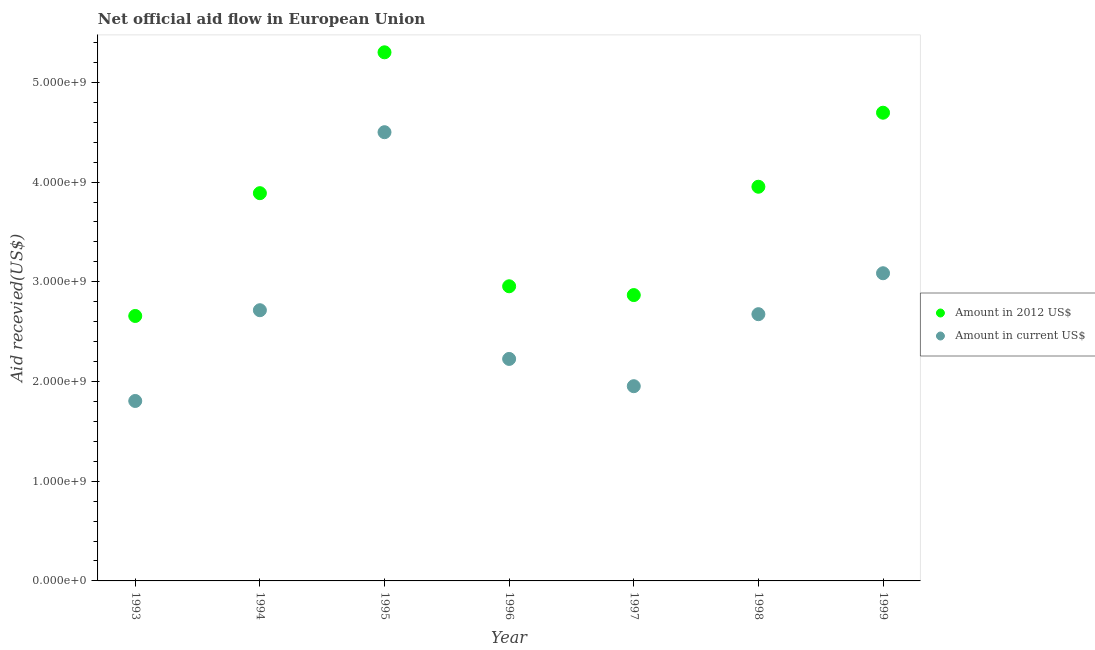How many different coloured dotlines are there?
Make the answer very short. 2. Is the number of dotlines equal to the number of legend labels?
Make the answer very short. Yes. What is the amount of aid received(expressed in 2012 us$) in 1995?
Ensure brevity in your answer.  5.30e+09. Across all years, what is the maximum amount of aid received(expressed in 2012 us$)?
Provide a succinct answer. 5.30e+09. Across all years, what is the minimum amount of aid received(expressed in us$)?
Your answer should be compact. 1.80e+09. In which year was the amount of aid received(expressed in us$) maximum?
Give a very brief answer. 1995. In which year was the amount of aid received(expressed in us$) minimum?
Provide a succinct answer. 1993. What is the total amount of aid received(expressed in 2012 us$) in the graph?
Your answer should be compact. 2.63e+1. What is the difference between the amount of aid received(expressed in 2012 us$) in 1998 and that in 1999?
Provide a succinct answer. -7.42e+08. What is the difference between the amount of aid received(expressed in 2012 us$) in 1997 and the amount of aid received(expressed in us$) in 1996?
Ensure brevity in your answer.  6.40e+08. What is the average amount of aid received(expressed in us$) per year?
Your response must be concise. 2.71e+09. In the year 1997, what is the difference between the amount of aid received(expressed in us$) and amount of aid received(expressed in 2012 us$)?
Provide a succinct answer. -9.14e+08. In how many years, is the amount of aid received(expressed in us$) greater than 4000000000 US$?
Offer a very short reply. 1. What is the ratio of the amount of aid received(expressed in 2012 us$) in 1993 to that in 1999?
Give a very brief answer. 0.57. Is the difference between the amount of aid received(expressed in us$) in 1993 and 1996 greater than the difference between the amount of aid received(expressed in 2012 us$) in 1993 and 1996?
Your answer should be very brief. No. What is the difference between the highest and the second highest amount of aid received(expressed in us$)?
Offer a terse response. 1.41e+09. What is the difference between the highest and the lowest amount of aid received(expressed in 2012 us$)?
Your response must be concise. 2.64e+09. In how many years, is the amount of aid received(expressed in us$) greater than the average amount of aid received(expressed in us$) taken over all years?
Give a very brief answer. 3. Is the amount of aid received(expressed in us$) strictly greater than the amount of aid received(expressed in 2012 us$) over the years?
Ensure brevity in your answer.  No. How many dotlines are there?
Your response must be concise. 2. How many years are there in the graph?
Offer a terse response. 7. Are the values on the major ticks of Y-axis written in scientific E-notation?
Give a very brief answer. Yes. Does the graph contain any zero values?
Give a very brief answer. No. Where does the legend appear in the graph?
Offer a very short reply. Center right. How are the legend labels stacked?
Your response must be concise. Vertical. What is the title of the graph?
Keep it short and to the point. Net official aid flow in European Union. What is the label or title of the Y-axis?
Ensure brevity in your answer.  Aid recevied(US$). What is the Aid recevied(US$) of Amount in 2012 US$ in 1993?
Provide a succinct answer. 2.66e+09. What is the Aid recevied(US$) of Amount in current US$ in 1993?
Ensure brevity in your answer.  1.80e+09. What is the Aid recevied(US$) in Amount in 2012 US$ in 1994?
Give a very brief answer. 3.89e+09. What is the Aid recevied(US$) of Amount in current US$ in 1994?
Provide a succinct answer. 2.71e+09. What is the Aid recevied(US$) of Amount in 2012 US$ in 1995?
Provide a succinct answer. 5.30e+09. What is the Aid recevied(US$) in Amount in current US$ in 1995?
Your answer should be compact. 4.50e+09. What is the Aid recevied(US$) of Amount in 2012 US$ in 1996?
Make the answer very short. 2.96e+09. What is the Aid recevied(US$) of Amount in current US$ in 1996?
Offer a terse response. 2.23e+09. What is the Aid recevied(US$) of Amount in 2012 US$ in 1997?
Your answer should be compact. 2.87e+09. What is the Aid recevied(US$) of Amount in current US$ in 1997?
Provide a short and direct response. 1.95e+09. What is the Aid recevied(US$) in Amount in 2012 US$ in 1998?
Your response must be concise. 3.95e+09. What is the Aid recevied(US$) of Amount in current US$ in 1998?
Keep it short and to the point. 2.68e+09. What is the Aid recevied(US$) in Amount in 2012 US$ in 1999?
Your answer should be compact. 4.70e+09. What is the Aid recevied(US$) of Amount in current US$ in 1999?
Give a very brief answer. 3.09e+09. Across all years, what is the maximum Aid recevied(US$) in Amount in 2012 US$?
Ensure brevity in your answer.  5.30e+09. Across all years, what is the maximum Aid recevied(US$) in Amount in current US$?
Offer a terse response. 4.50e+09. Across all years, what is the minimum Aid recevied(US$) of Amount in 2012 US$?
Keep it short and to the point. 2.66e+09. Across all years, what is the minimum Aid recevied(US$) in Amount in current US$?
Your answer should be compact. 1.80e+09. What is the total Aid recevied(US$) of Amount in 2012 US$ in the graph?
Ensure brevity in your answer.  2.63e+1. What is the total Aid recevied(US$) of Amount in current US$ in the graph?
Your response must be concise. 1.90e+1. What is the difference between the Aid recevied(US$) in Amount in 2012 US$ in 1993 and that in 1994?
Make the answer very short. -1.23e+09. What is the difference between the Aid recevied(US$) of Amount in current US$ in 1993 and that in 1994?
Provide a succinct answer. -9.10e+08. What is the difference between the Aid recevied(US$) of Amount in 2012 US$ in 1993 and that in 1995?
Offer a terse response. -2.64e+09. What is the difference between the Aid recevied(US$) in Amount in current US$ in 1993 and that in 1995?
Provide a succinct answer. -2.70e+09. What is the difference between the Aid recevied(US$) in Amount in 2012 US$ in 1993 and that in 1996?
Offer a terse response. -2.98e+08. What is the difference between the Aid recevied(US$) of Amount in current US$ in 1993 and that in 1996?
Your response must be concise. -4.22e+08. What is the difference between the Aid recevied(US$) of Amount in 2012 US$ in 1993 and that in 1997?
Make the answer very short. -2.10e+08. What is the difference between the Aid recevied(US$) of Amount in current US$ in 1993 and that in 1997?
Your answer should be compact. -1.48e+08. What is the difference between the Aid recevied(US$) in Amount in 2012 US$ in 1993 and that in 1998?
Ensure brevity in your answer.  -1.30e+09. What is the difference between the Aid recevied(US$) in Amount in current US$ in 1993 and that in 1998?
Your answer should be compact. -8.70e+08. What is the difference between the Aid recevied(US$) in Amount in 2012 US$ in 1993 and that in 1999?
Offer a very short reply. -2.04e+09. What is the difference between the Aid recevied(US$) of Amount in current US$ in 1993 and that in 1999?
Keep it short and to the point. -1.28e+09. What is the difference between the Aid recevied(US$) of Amount in 2012 US$ in 1994 and that in 1995?
Your answer should be compact. -1.41e+09. What is the difference between the Aid recevied(US$) of Amount in current US$ in 1994 and that in 1995?
Your answer should be compact. -1.79e+09. What is the difference between the Aid recevied(US$) of Amount in 2012 US$ in 1994 and that in 1996?
Provide a succinct answer. 9.34e+08. What is the difference between the Aid recevied(US$) in Amount in current US$ in 1994 and that in 1996?
Offer a very short reply. 4.89e+08. What is the difference between the Aid recevied(US$) in Amount in 2012 US$ in 1994 and that in 1997?
Offer a terse response. 1.02e+09. What is the difference between the Aid recevied(US$) of Amount in current US$ in 1994 and that in 1997?
Make the answer very short. 7.62e+08. What is the difference between the Aid recevied(US$) of Amount in 2012 US$ in 1994 and that in 1998?
Keep it short and to the point. -6.46e+07. What is the difference between the Aid recevied(US$) of Amount in current US$ in 1994 and that in 1998?
Make the answer very short. 3.98e+07. What is the difference between the Aid recevied(US$) in Amount in 2012 US$ in 1994 and that in 1999?
Offer a terse response. -8.07e+08. What is the difference between the Aid recevied(US$) of Amount in current US$ in 1994 and that in 1999?
Provide a short and direct response. -3.71e+08. What is the difference between the Aid recevied(US$) in Amount in 2012 US$ in 1995 and that in 1996?
Provide a succinct answer. 2.35e+09. What is the difference between the Aid recevied(US$) of Amount in current US$ in 1995 and that in 1996?
Your answer should be very brief. 2.27e+09. What is the difference between the Aid recevied(US$) of Amount in 2012 US$ in 1995 and that in 1997?
Keep it short and to the point. 2.43e+09. What is the difference between the Aid recevied(US$) of Amount in current US$ in 1995 and that in 1997?
Provide a short and direct response. 2.55e+09. What is the difference between the Aid recevied(US$) of Amount in 2012 US$ in 1995 and that in 1998?
Make the answer very short. 1.35e+09. What is the difference between the Aid recevied(US$) of Amount in current US$ in 1995 and that in 1998?
Provide a short and direct response. 1.83e+09. What is the difference between the Aid recevied(US$) of Amount in 2012 US$ in 1995 and that in 1999?
Your answer should be compact. 6.06e+08. What is the difference between the Aid recevied(US$) of Amount in current US$ in 1995 and that in 1999?
Provide a succinct answer. 1.41e+09. What is the difference between the Aid recevied(US$) in Amount in 2012 US$ in 1996 and that in 1997?
Keep it short and to the point. 8.82e+07. What is the difference between the Aid recevied(US$) in Amount in current US$ in 1996 and that in 1997?
Provide a succinct answer. 2.73e+08. What is the difference between the Aid recevied(US$) in Amount in 2012 US$ in 1996 and that in 1998?
Keep it short and to the point. -9.98e+08. What is the difference between the Aid recevied(US$) of Amount in current US$ in 1996 and that in 1998?
Give a very brief answer. -4.49e+08. What is the difference between the Aid recevied(US$) in Amount in 2012 US$ in 1996 and that in 1999?
Ensure brevity in your answer.  -1.74e+09. What is the difference between the Aid recevied(US$) in Amount in current US$ in 1996 and that in 1999?
Provide a succinct answer. -8.59e+08. What is the difference between the Aid recevied(US$) of Amount in 2012 US$ in 1997 and that in 1998?
Your answer should be compact. -1.09e+09. What is the difference between the Aid recevied(US$) of Amount in current US$ in 1997 and that in 1998?
Your answer should be compact. -7.22e+08. What is the difference between the Aid recevied(US$) of Amount in 2012 US$ in 1997 and that in 1999?
Give a very brief answer. -1.83e+09. What is the difference between the Aid recevied(US$) in Amount in current US$ in 1997 and that in 1999?
Offer a very short reply. -1.13e+09. What is the difference between the Aid recevied(US$) in Amount in 2012 US$ in 1998 and that in 1999?
Ensure brevity in your answer.  -7.42e+08. What is the difference between the Aid recevied(US$) of Amount in current US$ in 1998 and that in 1999?
Your answer should be compact. -4.11e+08. What is the difference between the Aid recevied(US$) in Amount in 2012 US$ in 1993 and the Aid recevied(US$) in Amount in current US$ in 1994?
Provide a short and direct response. -5.77e+07. What is the difference between the Aid recevied(US$) in Amount in 2012 US$ in 1993 and the Aid recevied(US$) in Amount in current US$ in 1995?
Keep it short and to the point. -1.84e+09. What is the difference between the Aid recevied(US$) of Amount in 2012 US$ in 1993 and the Aid recevied(US$) of Amount in current US$ in 1996?
Make the answer very short. 4.31e+08. What is the difference between the Aid recevied(US$) of Amount in 2012 US$ in 1993 and the Aid recevied(US$) of Amount in current US$ in 1997?
Keep it short and to the point. 7.04e+08. What is the difference between the Aid recevied(US$) in Amount in 2012 US$ in 1993 and the Aid recevied(US$) in Amount in current US$ in 1998?
Provide a short and direct response. -1.79e+07. What is the difference between the Aid recevied(US$) in Amount in 2012 US$ in 1993 and the Aid recevied(US$) in Amount in current US$ in 1999?
Offer a terse response. -4.29e+08. What is the difference between the Aid recevied(US$) of Amount in 2012 US$ in 1994 and the Aid recevied(US$) of Amount in current US$ in 1995?
Provide a short and direct response. -6.12e+08. What is the difference between the Aid recevied(US$) in Amount in 2012 US$ in 1994 and the Aid recevied(US$) in Amount in current US$ in 1996?
Offer a terse response. 1.66e+09. What is the difference between the Aid recevied(US$) of Amount in 2012 US$ in 1994 and the Aid recevied(US$) of Amount in current US$ in 1997?
Provide a short and direct response. 1.94e+09. What is the difference between the Aid recevied(US$) in Amount in 2012 US$ in 1994 and the Aid recevied(US$) in Amount in current US$ in 1998?
Make the answer very short. 1.21e+09. What is the difference between the Aid recevied(US$) of Amount in 2012 US$ in 1994 and the Aid recevied(US$) of Amount in current US$ in 1999?
Keep it short and to the point. 8.03e+08. What is the difference between the Aid recevied(US$) in Amount in 2012 US$ in 1995 and the Aid recevied(US$) in Amount in current US$ in 1996?
Your answer should be very brief. 3.08e+09. What is the difference between the Aid recevied(US$) in Amount in 2012 US$ in 1995 and the Aid recevied(US$) in Amount in current US$ in 1997?
Offer a terse response. 3.35e+09. What is the difference between the Aid recevied(US$) in Amount in 2012 US$ in 1995 and the Aid recevied(US$) in Amount in current US$ in 1998?
Keep it short and to the point. 2.63e+09. What is the difference between the Aid recevied(US$) in Amount in 2012 US$ in 1995 and the Aid recevied(US$) in Amount in current US$ in 1999?
Your answer should be compact. 2.22e+09. What is the difference between the Aid recevied(US$) of Amount in 2012 US$ in 1996 and the Aid recevied(US$) of Amount in current US$ in 1997?
Give a very brief answer. 1.00e+09. What is the difference between the Aid recevied(US$) in Amount in 2012 US$ in 1996 and the Aid recevied(US$) in Amount in current US$ in 1998?
Provide a short and direct response. 2.80e+08. What is the difference between the Aid recevied(US$) in Amount in 2012 US$ in 1996 and the Aid recevied(US$) in Amount in current US$ in 1999?
Provide a succinct answer. -1.31e+08. What is the difference between the Aid recevied(US$) in Amount in 2012 US$ in 1997 and the Aid recevied(US$) in Amount in current US$ in 1998?
Ensure brevity in your answer.  1.92e+08. What is the difference between the Aid recevied(US$) in Amount in 2012 US$ in 1997 and the Aid recevied(US$) in Amount in current US$ in 1999?
Your answer should be very brief. -2.19e+08. What is the difference between the Aid recevied(US$) of Amount in 2012 US$ in 1998 and the Aid recevied(US$) of Amount in current US$ in 1999?
Ensure brevity in your answer.  8.68e+08. What is the average Aid recevied(US$) of Amount in 2012 US$ per year?
Your response must be concise. 3.76e+09. What is the average Aid recevied(US$) in Amount in current US$ per year?
Offer a very short reply. 2.71e+09. In the year 1993, what is the difference between the Aid recevied(US$) in Amount in 2012 US$ and Aid recevied(US$) in Amount in current US$?
Your response must be concise. 8.53e+08. In the year 1994, what is the difference between the Aid recevied(US$) of Amount in 2012 US$ and Aid recevied(US$) of Amount in current US$?
Offer a very short reply. 1.17e+09. In the year 1995, what is the difference between the Aid recevied(US$) of Amount in 2012 US$ and Aid recevied(US$) of Amount in current US$?
Provide a short and direct response. 8.01e+08. In the year 1996, what is the difference between the Aid recevied(US$) of Amount in 2012 US$ and Aid recevied(US$) of Amount in current US$?
Ensure brevity in your answer.  7.29e+08. In the year 1997, what is the difference between the Aid recevied(US$) in Amount in 2012 US$ and Aid recevied(US$) in Amount in current US$?
Make the answer very short. 9.14e+08. In the year 1998, what is the difference between the Aid recevied(US$) in Amount in 2012 US$ and Aid recevied(US$) in Amount in current US$?
Keep it short and to the point. 1.28e+09. In the year 1999, what is the difference between the Aid recevied(US$) in Amount in 2012 US$ and Aid recevied(US$) in Amount in current US$?
Your response must be concise. 1.61e+09. What is the ratio of the Aid recevied(US$) of Amount in 2012 US$ in 1993 to that in 1994?
Offer a very short reply. 0.68. What is the ratio of the Aid recevied(US$) in Amount in current US$ in 1993 to that in 1994?
Make the answer very short. 0.66. What is the ratio of the Aid recevied(US$) of Amount in 2012 US$ in 1993 to that in 1995?
Your response must be concise. 0.5. What is the ratio of the Aid recevied(US$) of Amount in current US$ in 1993 to that in 1995?
Your response must be concise. 0.4. What is the ratio of the Aid recevied(US$) of Amount in 2012 US$ in 1993 to that in 1996?
Your answer should be compact. 0.9. What is the ratio of the Aid recevied(US$) of Amount in current US$ in 1993 to that in 1996?
Offer a terse response. 0.81. What is the ratio of the Aid recevied(US$) in Amount in 2012 US$ in 1993 to that in 1997?
Your answer should be very brief. 0.93. What is the ratio of the Aid recevied(US$) in Amount in current US$ in 1993 to that in 1997?
Provide a short and direct response. 0.92. What is the ratio of the Aid recevied(US$) of Amount in 2012 US$ in 1993 to that in 1998?
Your answer should be very brief. 0.67. What is the ratio of the Aid recevied(US$) of Amount in current US$ in 1993 to that in 1998?
Provide a short and direct response. 0.67. What is the ratio of the Aid recevied(US$) of Amount in 2012 US$ in 1993 to that in 1999?
Give a very brief answer. 0.57. What is the ratio of the Aid recevied(US$) in Amount in current US$ in 1993 to that in 1999?
Provide a succinct answer. 0.58. What is the ratio of the Aid recevied(US$) of Amount in 2012 US$ in 1994 to that in 1995?
Provide a short and direct response. 0.73. What is the ratio of the Aid recevied(US$) of Amount in current US$ in 1994 to that in 1995?
Keep it short and to the point. 0.6. What is the ratio of the Aid recevied(US$) in Amount in 2012 US$ in 1994 to that in 1996?
Make the answer very short. 1.32. What is the ratio of the Aid recevied(US$) in Amount in current US$ in 1994 to that in 1996?
Give a very brief answer. 1.22. What is the ratio of the Aid recevied(US$) in Amount in 2012 US$ in 1994 to that in 1997?
Offer a very short reply. 1.36. What is the ratio of the Aid recevied(US$) of Amount in current US$ in 1994 to that in 1997?
Keep it short and to the point. 1.39. What is the ratio of the Aid recevied(US$) in Amount in 2012 US$ in 1994 to that in 1998?
Give a very brief answer. 0.98. What is the ratio of the Aid recevied(US$) of Amount in current US$ in 1994 to that in 1998?
Your response must be concise. 1.01. What is the ratio of the Aid recevied(US$) in Amount in 2012 US$ in 1994 to that in 1999?
Ensure brevity in your answer.  0.83. What is the ratio of the Aid recevied(US$) of Amount in current US$ in 1994 to that in 1999?
Provide a short and direct response. 0.88. What is the ratio of the Aid recevied(US$) in Amount in 2012 US$ in 1995 to that in 1996?
Provide a short and direct response. 1.79. What is the ratio of the Aid recevied(US$) in Amount in current US$ in 1995 to that in 1996?
Your response must be concise. 2.02. What is the ratio of the Aid recevied(US$) of Amount in 2012 US$ in 1995 to that in 1997?
Your answer should be compact. 1.85. What is the ratio of the Aid recevied(US$) of Amount in current US$ in 1995 to that in 1997?
Ensure brevity in your answer.  2.3. What is the ratio of the Aid recevied(US$) of Amount in 2012 US$ in 1995 to that in 1998?
Keep it short and to the point. 1.34. What is the ratio of the Aid recevied(US$) in Amount in current US$ in 1995 to that in 1998?
Offer a very short reply. 1.68. What is the ratio of the Aid recevied(US$) of Amount in 2012 US$ in 1995 to that in 1999?
Offer a terse response. 1.13. What is the ratio of the Aid recevied(US$) of Amount in current US$ in 1995 to that in 1999?
Your answer should be very brief. 1.46. What is the ratio of the Aid recevied(US$) in Amount in 2012 US$ in 1996 to that in 1997?
Provide a short and direct response. 1.03. What is the ratio of the Aid recevied(US$) of Amount in current US$ in 1996 to that in 1997?
Keep it short and to the point. 1.14. What is the ratio of the Aid recevied(US$) of Amount in 2012 US$ in 1996 to that in 1998?
Your response must be concise. 0.75. What is the ratio of the Aid recevied(US$) of Amount in current US$ in 1996 to that in 1998?
Your response must be concise. 0.83. What is the ratio of the Aid recevied(US$) in Amount in 2012 US$ in 1996 to that in 1999?
Provide a succinct answer. 0.63. What is the ratio of the Aid recevied(US$) in Amount in current US$ in 1996 to that in 1999?
Offer a very short reply. 0.72. What is the ratio of the Aid recevied(US$) in Amount in 2012 US$ in 1997 to that in 1998?
Your response must be concise. 0.73. What is the ratio of the Aid recevied(US$) of Amount in current US$ in 1997 to that in 1998?
Offer a terse response. 0.73. What is the ratio of the Aid recevied(US$) in Amount in 2012 US$ in 1997 to that in 1999?
Your answer should be compact. 0.61. What is the ratio of the Aid recevied(US$) of Amount in current US$ in 1997 to that in 1999?
Provide a succinct answer. 0.63. What is the ratio of the Aid recevied(US$) of Amount in 2012 US$ in 1998 to that in 1999?
Make the answer very short. 0.84. What is the ratio of the Aid recevied(US$) of Amount in current US$ in 1998 to that in 1999?
Give a very brief answer. 0.87. What is the difference between the highest and the second highest Aid recevied(US$) of Amount in 2012 US$?
Offer a very short reply. 6.06e+08. What is the difference between the highest and the second highest Aid recevied(US$) in Amount in current US$?
Your answer should be very brief. 1.41e+09. What is the difference between the highest and the lowest Aid recevied(US$) in Amount in 2012 US$?
Make the answer very short. 2.64e+09. What is the difference between the highest and the lowest Aid recevied(US$) in Amount in current US$?
Offer a terse response. 2.70e+09. 